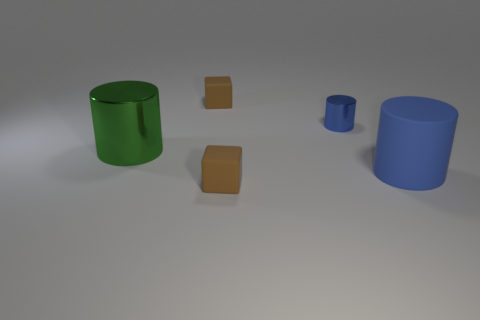Subtract all brown blocks. How many were subtracted if there are1brown blocks left? 1 Subtract all blue cylinders. How many cylinders are left? 1 Add 3 blue cubes. How many objects exist? 8 Subtract all green cylinders. How many cylinders are left? 2 Subtract all cylinders. How many objects are left? 2 Subtract all purple blocks. How many blue cylinders are left? 2 Subtract all big matte cylinders. Subtract all blocks. How many objects are left? 2 Add 1 small blue metal cylinders. How many small blue metal cylinders are left? 2 Add 5 large matte objects. How many large matte objects exist? 6 Subtract 0 purple cubes. How many objects are left? 5 